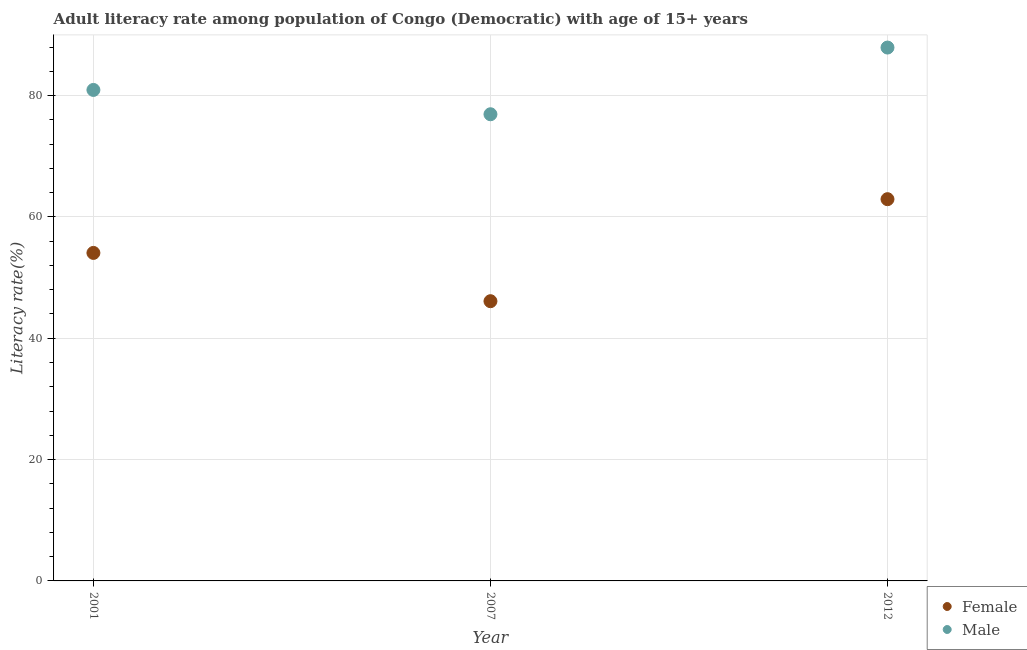Is the number of dotlines equal to the number of legend labels?
Make the answer very short. Yes. What is the female adult literacy rate in 2001?
Provide a short and direct response. 54.06. Across all years, what is the maximum female adult literacy rate?
Provide a short and direct response. 62.92. Across all years, what is the minimum male adult literacy rate?
Give a very brief answer. 76.92. In which year was the male adult literacy rate maximum?
Provide a succinct answer. 2012. In which year was the female adult literacy rate minimum?
Keep it short and to the point. 2007. What is the total female adult literacy rate in the graph?
Your answer should be very brief. 163.08. What is the difference between the male adult literacy rate in 2001 and that in 2007?
Provide a short and direct response. 4.01. What is the difference between the male adult literacy rate in 2007 and the female adult literacy rate in 2012?
Ensure brevity in your answer.  14. What is the average male adult literacy rate per year?
Provide a short and direct response. 81.92. In the year 2001, what is the difference between the male adult literacy rate and female adult literacy rate?
Your answer should be very brief. 26.86. What is the ratio of the female adult literacy rate in 2001 to that in 2012?
Your response must be concise. 0.86. Is the female adult literacy rate in 2001 less than that in 2007?
Your answer should be compact. No. What is the difference between the highest and the second highest male adult literacy rate?
Your answer should be very brief. 6.99. What is the difference between the highest and the lowest female adult literacy rate?
Your response must be concise. 16.81. Does the male adult literacy rate monotonically increase over the years?
Keep it short and to the point. No. How many dotlines are there?
Your response must be concise. 2. Does the graph contain any zero values?
Provide a succinct answer. No. Where does the legend appear in the graph?
Offer a terse response. Bottom right. How many legend labels are there?
Keep it short and to the point. 2. How are the legend labels stacked?
Your answer should be very brief. Vertical. What is the title of the graph?
Your answer should be compact. Adult literacy rate among population of Congo (Democratic) with age of 15+ years. Does "Formally registered" appear as one of the legend labels in the graph?
Keep it short and to the point. No. What is the label or title of the X-axis?
Keep it short and to the point. Year. What is the label or title of the Y-axis?
Your response must be concise. Literacy rate(%). What is the Literacy rate(%) in Female in 2001?
Offer a very short reply. 54.06. What is the Literacy rate(%) of Male in 2001?
Make the answer very short. 80.92. What is the Literacy rate(%) of Female in 2007?
Your answer should be very brief. 46.1. What is the Literacy rate(%) in Male in 2007?
Give a very brief answer. 76.92. What is the Literacy rate(%) of Female in 2012?
Your response must be concise. 62.92. What is the Literacy rate(%) of Male in 2012?
Provide a succinct answer. 87.91. Across all years, what is the maximum Literacy rate(%) in Female?
Provide a short and direct response. 62.92. Across all years, what is the maximum Literacy rate(%) of Male?
Your answer should be compact. 87.91. Across all years, what is the minimum Literacy rate(%) in Female?
Offer a terse response. 46.1. Across all years, what is the minimum Literacy rate(%) of Male?
Give a very brief answer. 76.92. What is the total Literacy rate(%) in Female in the graph?
Offer a very short reply. 163.08. What is the total Literacy rate(%) in Male in the graph?
Keep it short and to the point. 245.75. What is the difference between the Literacy rate(%) in Female in 2001 and that in 2007?
Your answer should be compact. 7.96. What is the difference between the Literacy rate(%) of Male in 2001 and that in 2007?
Your response must be concise. 4.01. What is the difference between the Literacy rate(%) in Female in 2001 and that in 2012?
Your response must be concise. -8.86. What is the difference between the Literacy rate(%) in Male in 2001 and that in 2012?
Offer a very short reply. -6.99. What is the difference between the Literacy rate(%) of Female in 2007 and that in 2012?
Make the answer very short. -16.81. What is the difference between the Literacy rate(%) in Male in 2007 and that in 2012?
Offer a terse response. -10.99. What is the difference between the Literacy rate(%) of Female in 2001 and the Literacy rate(%) of Male in 2007?
Ensure brevity in your answer.  -22.85. What is the difference between the Literacy rate(%) in Female in 2001 and the Literacy rate(%) in Male in 2012?
Provide a succinct answer. -33.85. What is the difference between the Literacy rate(%) of Female in 2007 and the Literacy rate(%) of Male in 2012?
Ensure brevity in your answer.  -41.8. What is the average Literacy rate(%) in Female per year?
Your answer should be very brief. 54.36. What is the average Literacy rate(%) of Male per year?
Provide a short and direct response. 81.92. In the year 2001, what is the difference between the Literacy rate(%) in Female and Literacy rate(%) in Male?
Make the answer very short. -26.86. In the year 2007, what is the difference between the Literacy rate(%) in Female and Literacy rate(%) in Male?
Give a very brief answer. -30.81. In the year 2012, what is the difference between the Literacy rate(%) of Female and Literacy rate(%) of Male?
Give a very brief answer. -24.99. What is the ratio of the Literacy rate(%) in Female in 2001 to that in 2007?
Provide a succinct answer. 1.17. What is the ratio of the Literacy rate(%) of Male in 2001 to that in 2007?
Offer a very short reply. 1.05. What is the ratio of the Literacy rate(%) in Female in 2001 to that in 2012?
Your answer should be very brief. 0.86. What is the ratio of the Literacy rate(%) of Male in 2001 to that in 2012?
Ensure brevity in your answer.  0.92. What is the ratio of the Literacy rate(%) in Female in 2007 to that in 2012?
Your answer should be very brief. 0.73. What is the ratio of the Literacy rate(%) in Male in 2007 to that in 2012?
Your response must be concise. 0.88. What is the difference between the highest and the second highest Literacy rate(%) of Female?
Make the answer very short. 8.86. What is the difference between the highest and the second highest Literacy rate(%) in Male?
Offer a very short reply. 6.99. What is the difference between the highest and the lowest Literacy rate(%) in Female?
Provide a succinct answer. 16.81. What is the difference between the highest and the lowest Literacy rate(%) of Male?
Your answer should be compact. 10.99. 